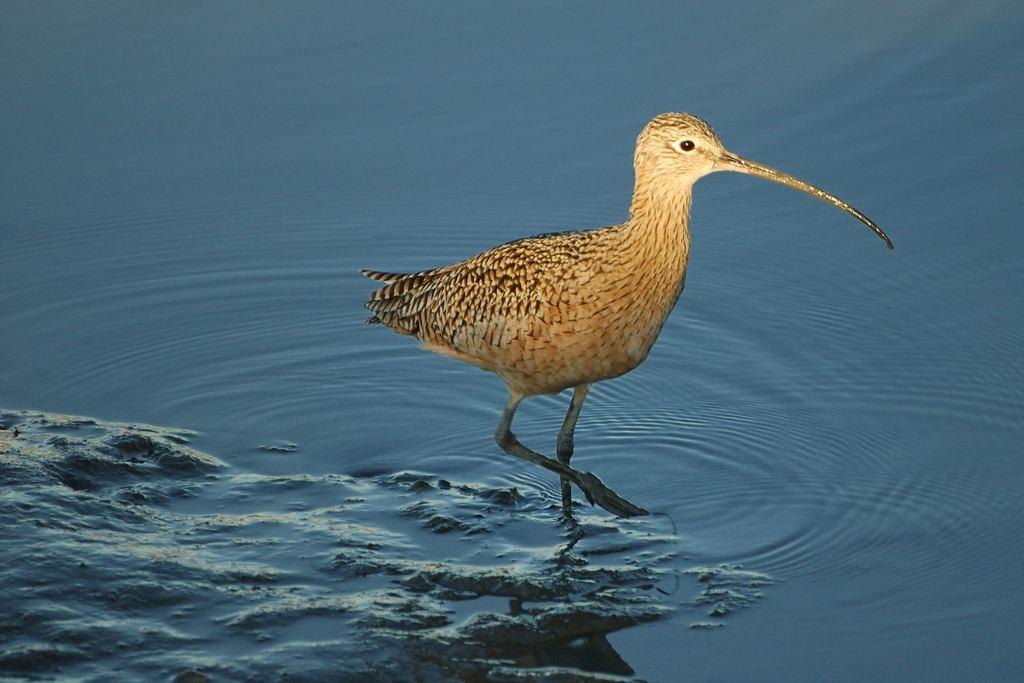What is present in the image that is not solid? There is water visible in the image. What type of animal can be seen in the image? There is a bird in the image. What type of spade is the bird using to dig in the image? There is no spade present in the image, and the bird is not shown digging. 